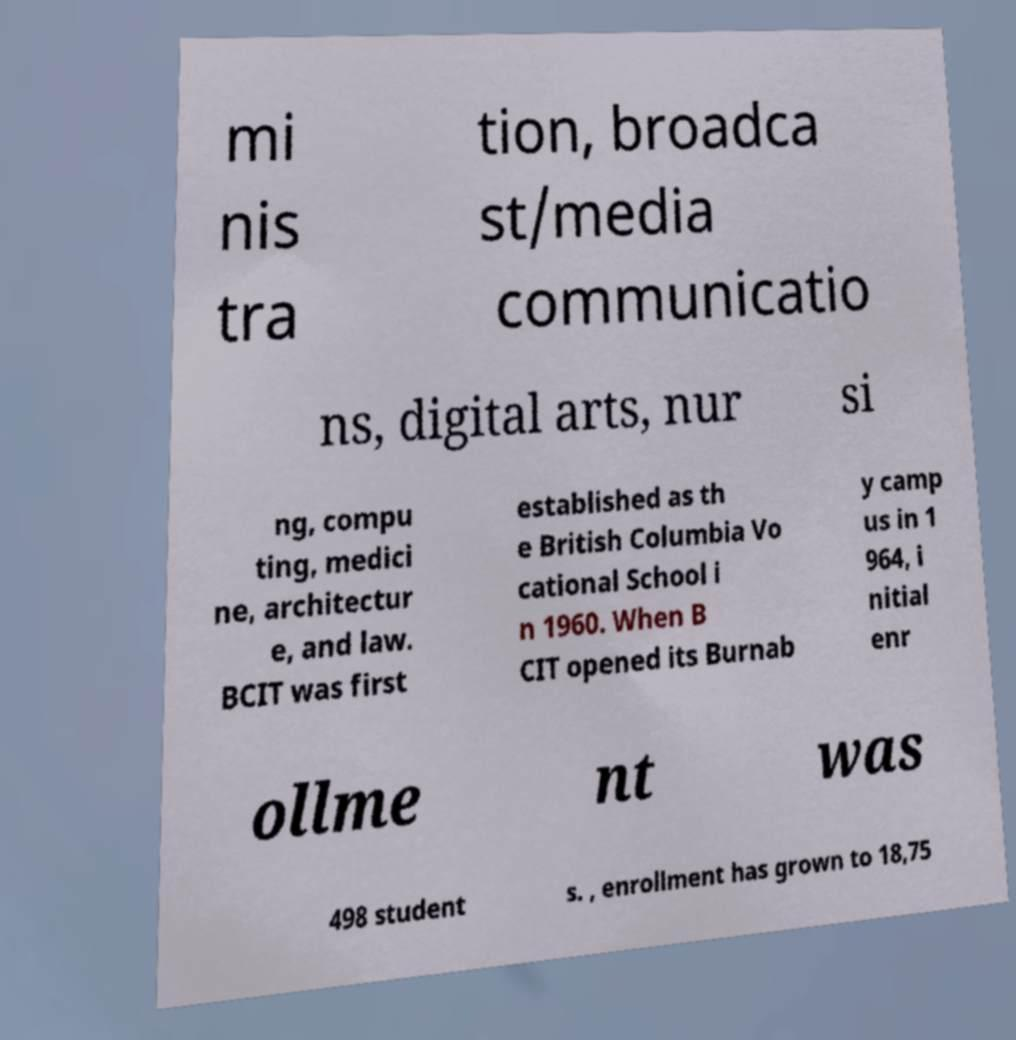I need the written content from this picture converted into text. Can you do that? mi nis tra tion, broadca st/media communicatio ns, digital arts, nur si ng, compu ting, medici ne, architectur e, and law. BCIT was first established as th e British Columbia Vo cational School i n 1960. When B CIT opened its Burnab y camp us in 1 964, i nitial enr ollme nt was 498 student s. , enrollment has grown to 18,75 